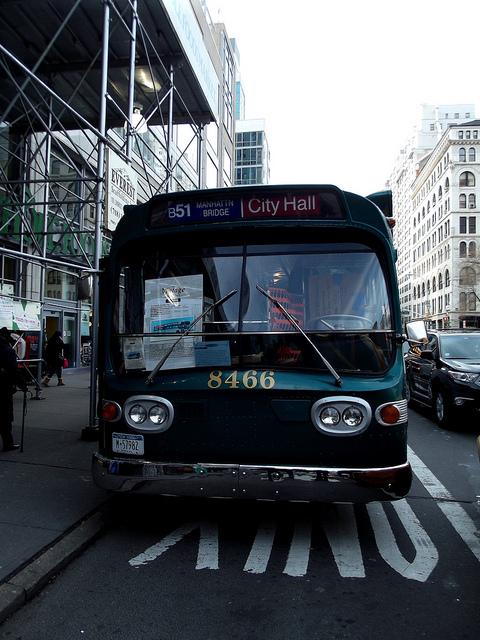What number is on the bus front?
Be succinct. 8466. Where is this bus going?
Write a very short answer. City hall. Is the bus parked?
Give a very brief answer. Yes. What is the number under the windshield?
Write a very short answer. 8466. 